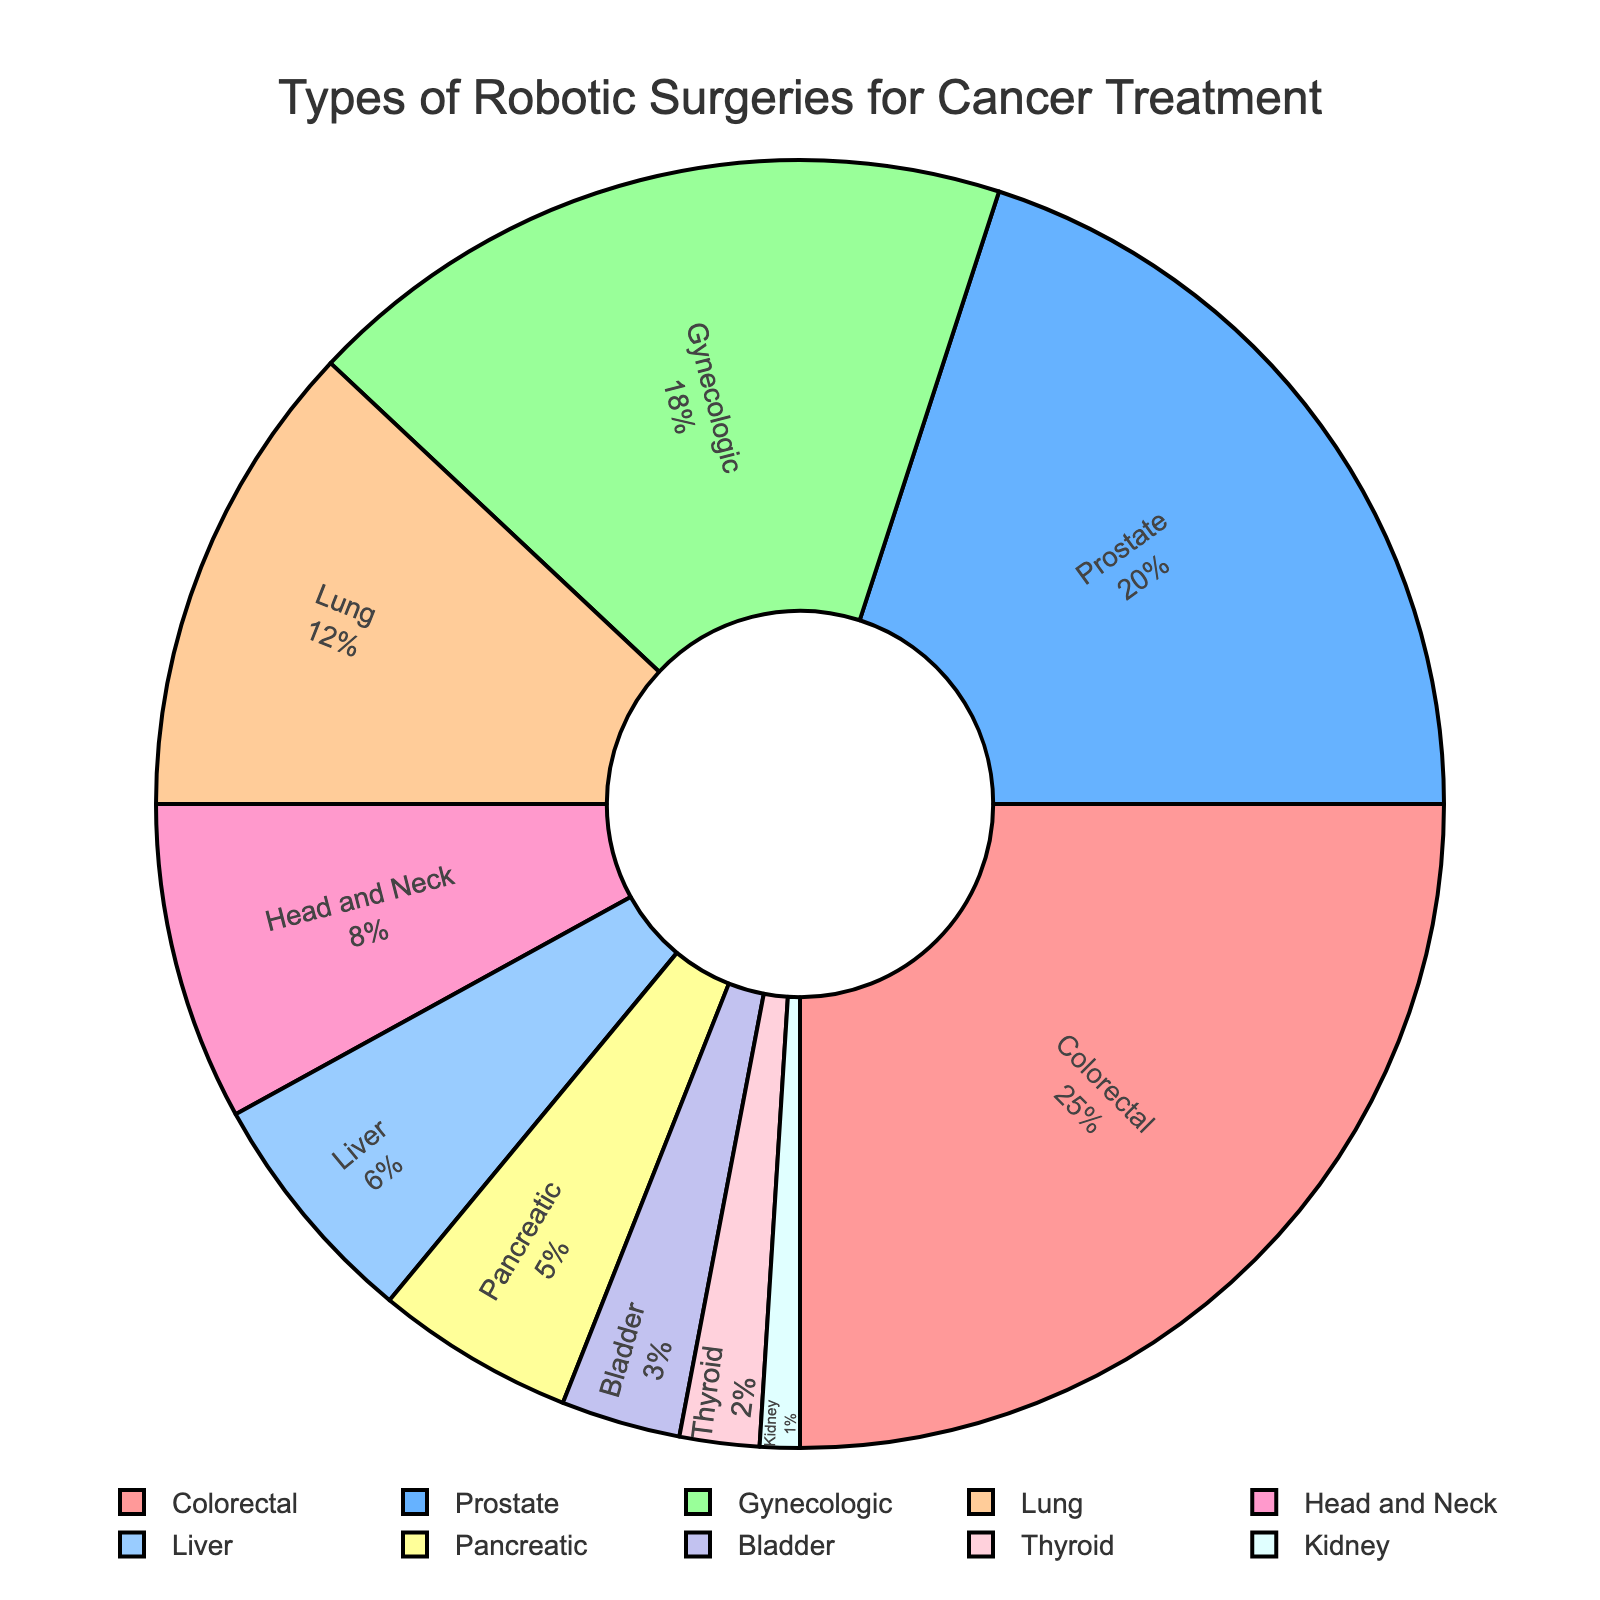what is the most common type of robotic surgery performed for cancer treatment? The figure shows various types of cancer surgeries and their respective percentages. The largest section of the pie chart represents colorectal cancer at 25%, making it the most common.
Answer: Colorectal What percentage of robotic surgeries is performed for prostate cancer? The figure clearly labels each cancer type with its corresponding percentage. Prostate cancer's section is labeled as 20%.
Answer: 20% Which three cancer types have the smallest percentage of robotic surgeries, and what are their combined percentages? The three smallest sections of the pie chart correspond to kidney cancer (1%), thyroid cancer (2%), and bladder cancer (3%). Adding these percentages together: 1% + 2% + 3% = 6%.
Answer: 6% How much larger is the percentage of colorectal cancer surgeries compared to kidney cancer surgeries? Colorectal cancer's section is 25%, and kidney cancer's section is 1%. The difference is found by subtracting the smaller percentage from the larger: 25% - 1% = 24%.
Answer: 24% Is the percentage of gynecologic cancer surgeries closer to that of prostate cancer or lung cancer? Gynecologic cancer surgeries make up 18%, prostate cancer 20%, and lung cancer 12%. The difference between gynecologic and prostate is 2% (20% - 18%), and the difference between gynecologic and lung is 6% (18% - 12%). Therefore, 18% is closer to 20% than to 12%.
Answer: Prostate cancer Which cancer types are represented with the color red and blue in the pie chart? By examining the colors assigned in the data, the red section represents colorectal cancer, and the blue section represents prostate cancer.
Answer: Colorectal and prostate How much larger in percentage is gynecologic robotic surgery compared to liver robotic surgery? Gynecologic cancer surgeries are 18%, and liver cancer surgeries are 6%. The difference is calculated as 18% - 6% = 12%.
Answer: 12% What is the ratio of bladder cancer surgeries to pancreatic cancer surgeries? Bladder cancer makes up 3%, and pancreatic cancer makes up 5%. The ratio is found by dividing the percentages: 3%/5% = 0.6.
Answer: 0.6 How many types of cancer have a percentage greater than 10% for robotic surgeries? The figure lists colorectal (25%), prostate (20%), gynecologic (18%), and lung (12%) as the cancer types with percentages greater than 10%. Thus, there are 4 types.
Answer: 4 